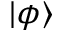<formula> <loc_0><loc_0><loc_500><loc_500>| \phi \rangle</formula> 